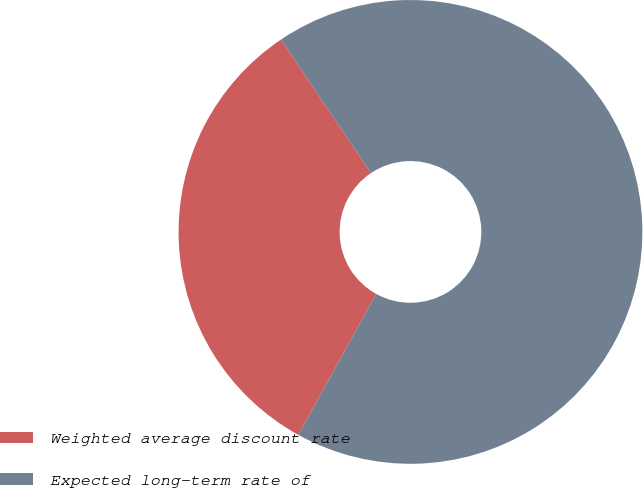Convert chart to OTSL. <chart><loc_0><loc_0><loc_500><loc_500><pie_chart><fcel>Weighted average discount rate<fcel>Expected long-term rate of<nl><fcel>32.55%<fcel>67.45%<nl></chart> 